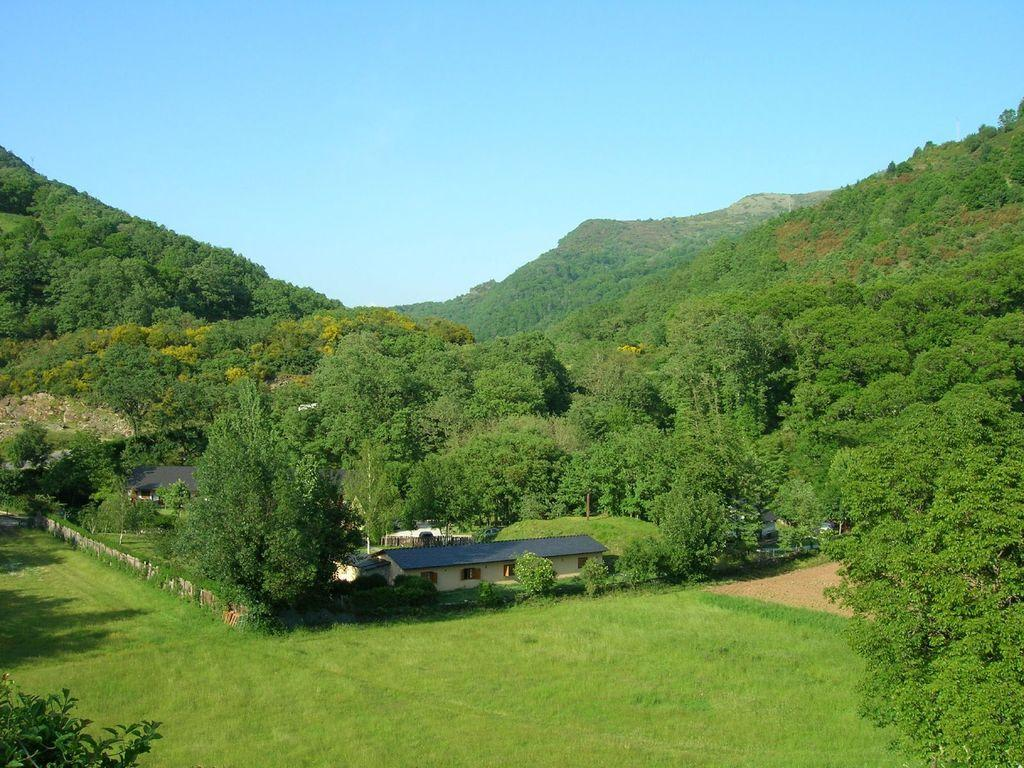What type of vegetation is present in the image? There are trees in the image. What color are the trees? The trees are green. What type of structures can be seen in the image? There are houses in the image. What color is the sky in the image? The sky is blue. Is there a tent visible in the image? No, there is no tent present in the image. Does the existence of the trees in the image prove the existence of a higher power? The presence of trees in the image does not prove the existence of a higher power; it simply shows that trees are part of the image. 